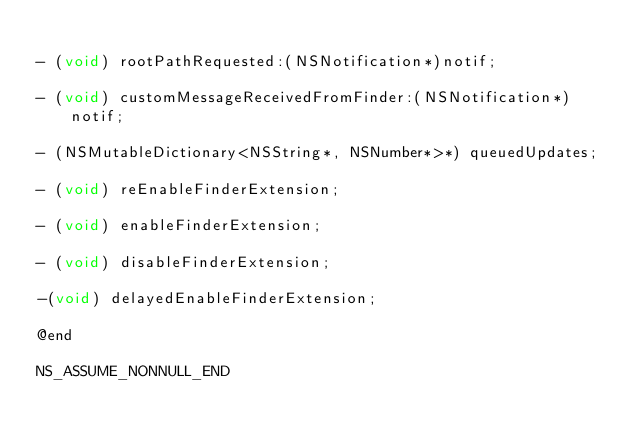Convert code to text. <code><loc_0><loc_0><loc_500><loc_500><_C_>
- (void) rootPathRequested:(NSNotification*)notif;

- (void) customMessageReceivedFromFinder:(NSNotification*)notif;

- (NSMutableDictionary<NSString*, NSNumber*>*) queuedUpdates;

- (void) reEnableFinderExtension;

- (void) enableFinderExtension;

- (void) disableFinderExtension;

-(void) delayedEnableFinderExtension;

@end

NS_ASSUME_NONNULL_END
</code> 